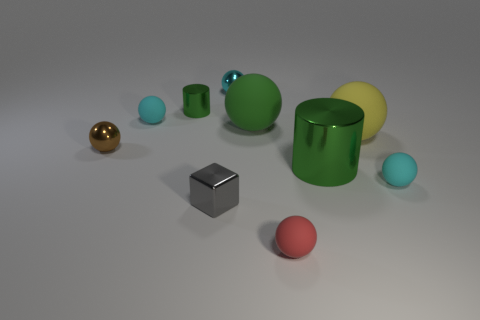Subtract all brown balls. How many balls are left? 6 Subtract all green cylinders. How many cyan spheres are left? 3 Subtract 4 balls. How many balls are left? 3 Subtract all brown spheres. How many spheres are left? 6 Subtract all green spheres. Subtract all red cylinders. How many spheres are left? 6 Subtract all balls. How many objects are left? 3 Subtract all small red things. Subtract all gray metal objects. How many objects are left? 8 Add 2 tiny gray metal things. How many tiny gray metal things are left? 3 Add 1 big metal spheres. How many big metal spheres exist? 1 Subtract 1 brown balls. How many objects are left? 9 